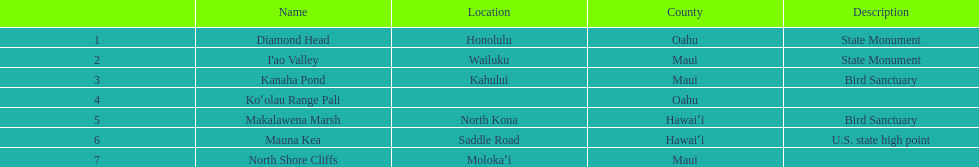What are the total number of landmarks located in maui? 3. 